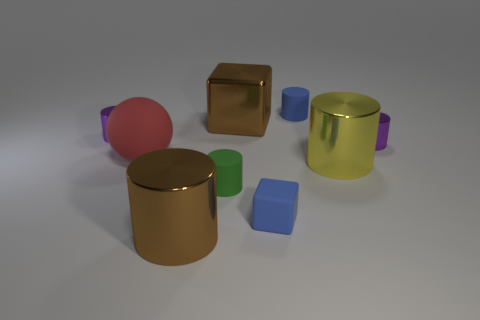Are there any small purple things made of the same material as the brown cylinder?
Give a very brief answer. Yes. What number of cylinders are brown objects or small purple shiny things?
Make the answer very short. 3. Are there any small rubber objects that are behind the purple cylinder to the left of the big brown metallic cylinder?
Your answer should be very brief. Yes. Is the number of tiny matte blocks less than the number of small shiny objects?
Keep it short and to the point. Yes. How many cyan matte things are the same shape as the tiny green thing?
Your answer should be compact. 0. How many brown things are shiny cylinders or tiny metal cylinders?
Your answer should be compact. 1. How big is the purple metallic object that is on the left side of the brown metallic object in front of the small green thing?
Make the answer very short. Small. There is a yellow object that is the same shape as the small green rubber thing; what material is it?
Provide a short and direct response. Metal. What number of metallic cubes are the same size as the red thing?
Provide a short and direct response. 1. Do the green cylinder and the blue cylinder have the same size?
Your answer should be compact. Yes. 